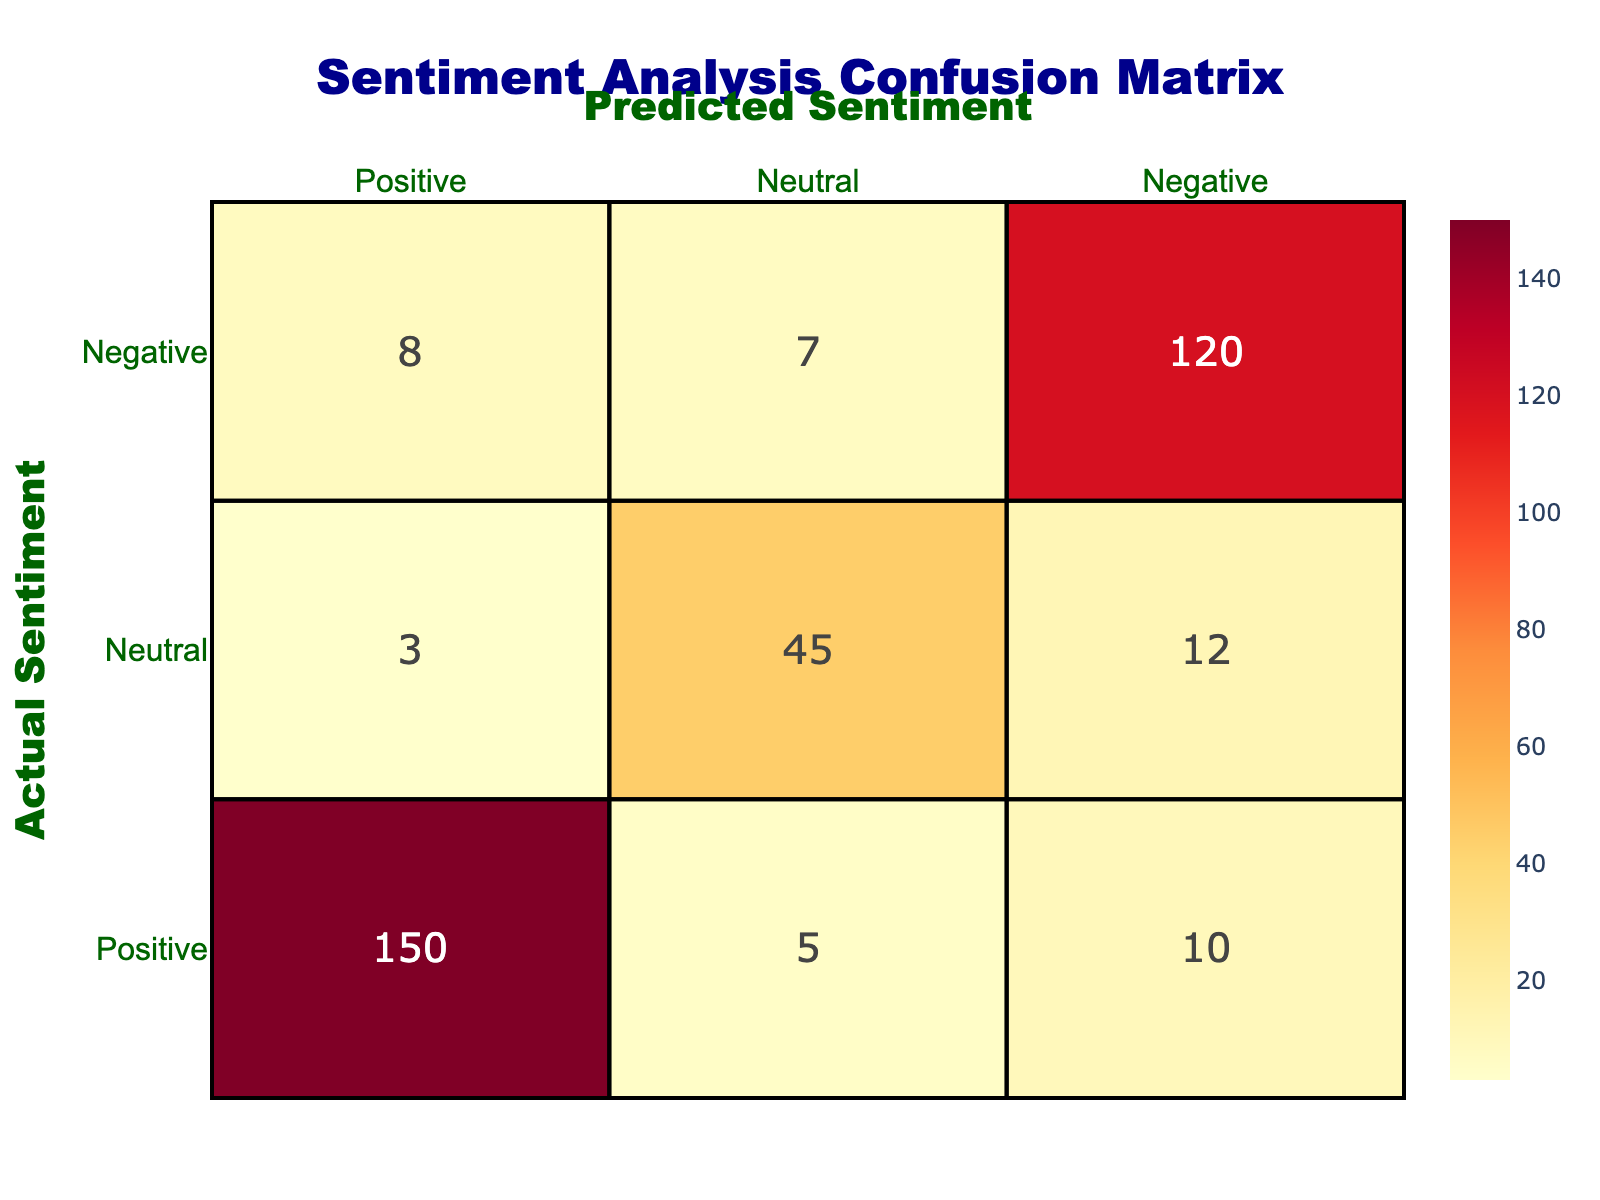What is the total count of positive sentiments predicted by the model? To find the total count of positive sentiments predicted, we look at the column "Predictive Sentiment" for "Positive". The values in this column for positive sentiment are 150 (Actual Positive), 8 (Actual Negative), and 3 (Actual Neutral). Adding these gives us 150 + 8 + 3 = 161.
Answer: 161 How many negative sentiments were correctly predicted? The number of correctly predicted negative sentiments is found in the "Negative" row under the "Predictive Sentiment" column. Here we see that there are 120 occurrences where the actual sentiment was negative and the prediction was also negative. Therefore, the count is simply 120.
Answer: 120 What percentage of actual positive sentiments were predicted as negative? To find the percentage of actual positive sentiments predicted as negative, we look at the number of actual positive sentiments (150 + 10 + 5 = 165). The number of positive sentiments predicted as negative is 10. The calculation is (10 / 165) * 100 = 6.06%.
Answer: 6.06% Is the total predicted neutral sentiment greater than the total predicted positive sentiment? We calculate the total predicted neutral sentiment by summing the relevant entries: 5 (actual Positive) + 7 (actual Negative) + 45 (actual Neutral) = 57. For positive sentiment: 150 (actual Positive) + 8 (actual Negative) + 3 (actual Neutral) = 161. Since 57 is not greater than 161, the answer is no.
Answer: No How many counts were predicted as negative while the actual sentiments were neutral? According to the table, there are 12 instances where the actual sentiment was Neutral and the predicted sentiment was Negative. This value can be found directly from the confusion matrix.
Answer: 12 What is the total count of sentiments where the actual sentiment is neutral? To find the total count of neutral sentiments, we sum all the counts in the "Neutral" row (3 (predicted Positive) + 12 (predicted Negative) + 45 (predicted Neutral)) = 60. Therefore, the total count of neutral actual sentiments is 60.
Answer: 60 What is the sum of the counts where the prediction was neutral? The counts for when the prediction was neutral are 5 (actual Positive) + 7 (actual Negative) + 45 (actual Neutral) = 57. Therefore, the sum of counts where the prediction was neutral is 57.
Answer: 57 Which actual sentiment category had the highest prediction count? Looking at the table, we can see that the actual sentiment "Positive" has a prediction count of 150, whereas "Negative" has 120, and "Neutral" has 45. The highest count is clearly for the actual Positive sentiment category.
Answer: Positive 